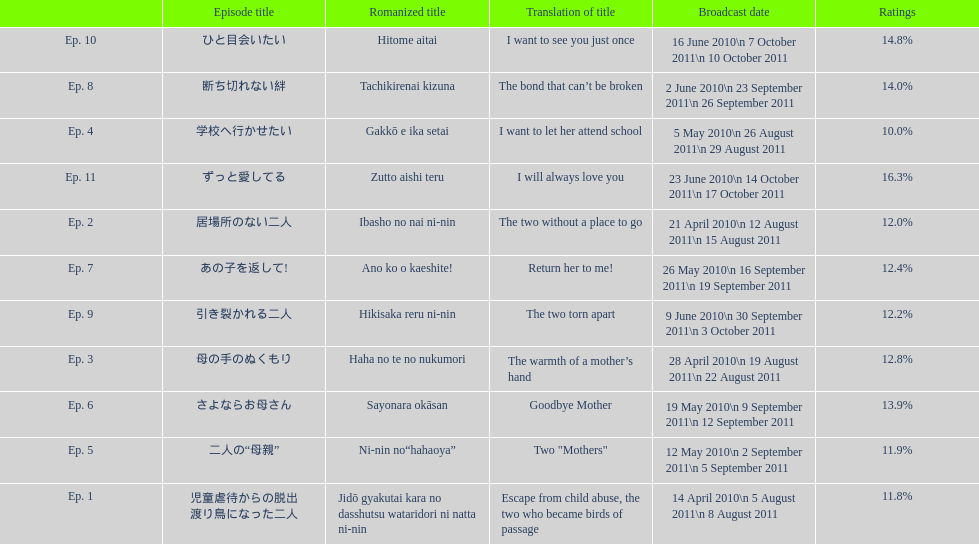How many episodes are below 14%? 8. 